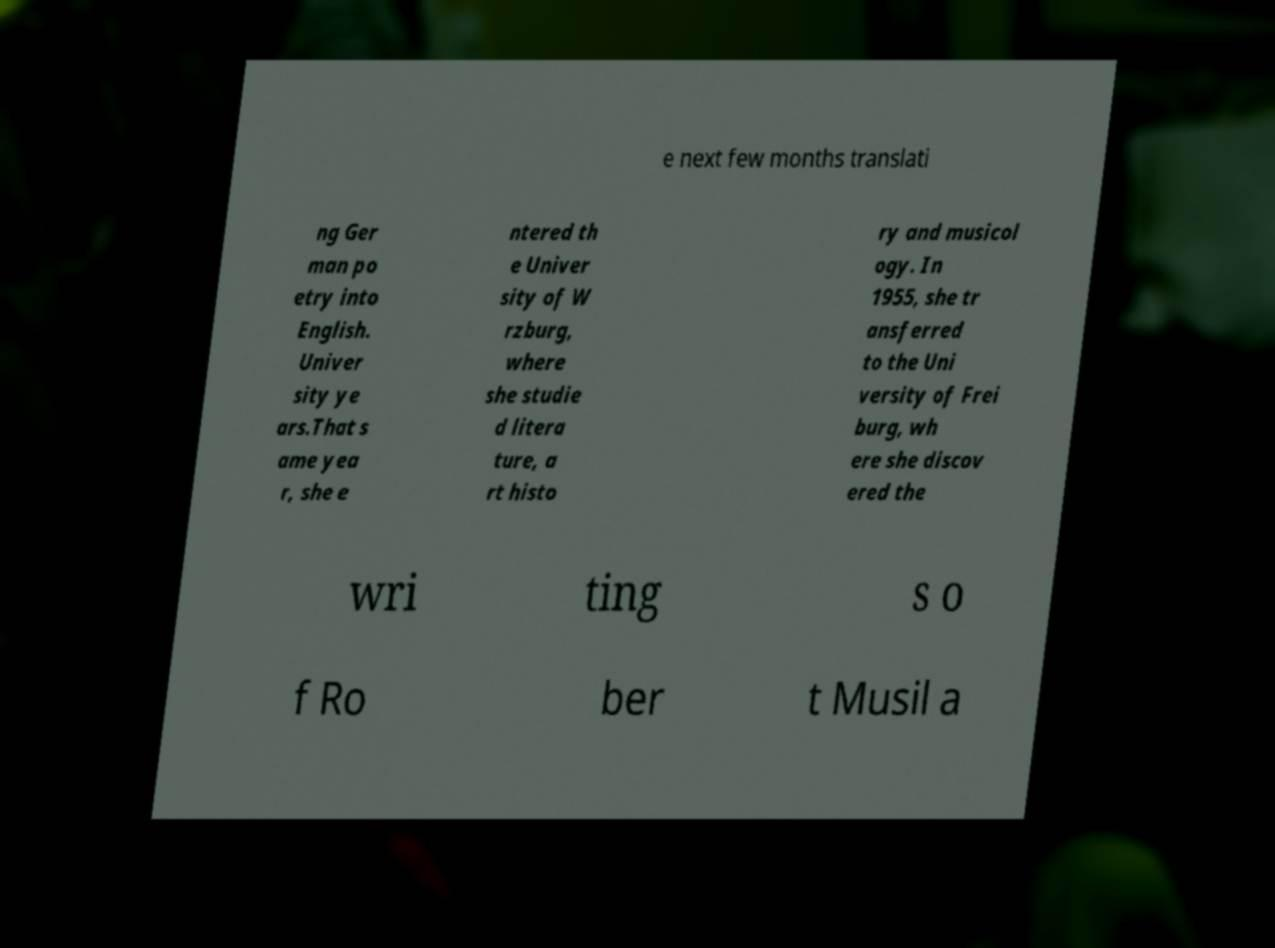Please identify and transcribe the text found in this image. e next few months translati ng Ger man po etry into English. Univer sity ye ars.That s ame yea r, she e ntered th e Univer sity of W rzburg, where she studie d litera ture, a rt histo ry and musicol ogy. In 1955, she tr ansferred to the Uni versity of Frei burg, wh ere she discov ered the wri ting s o f Ro ber t Musil a 